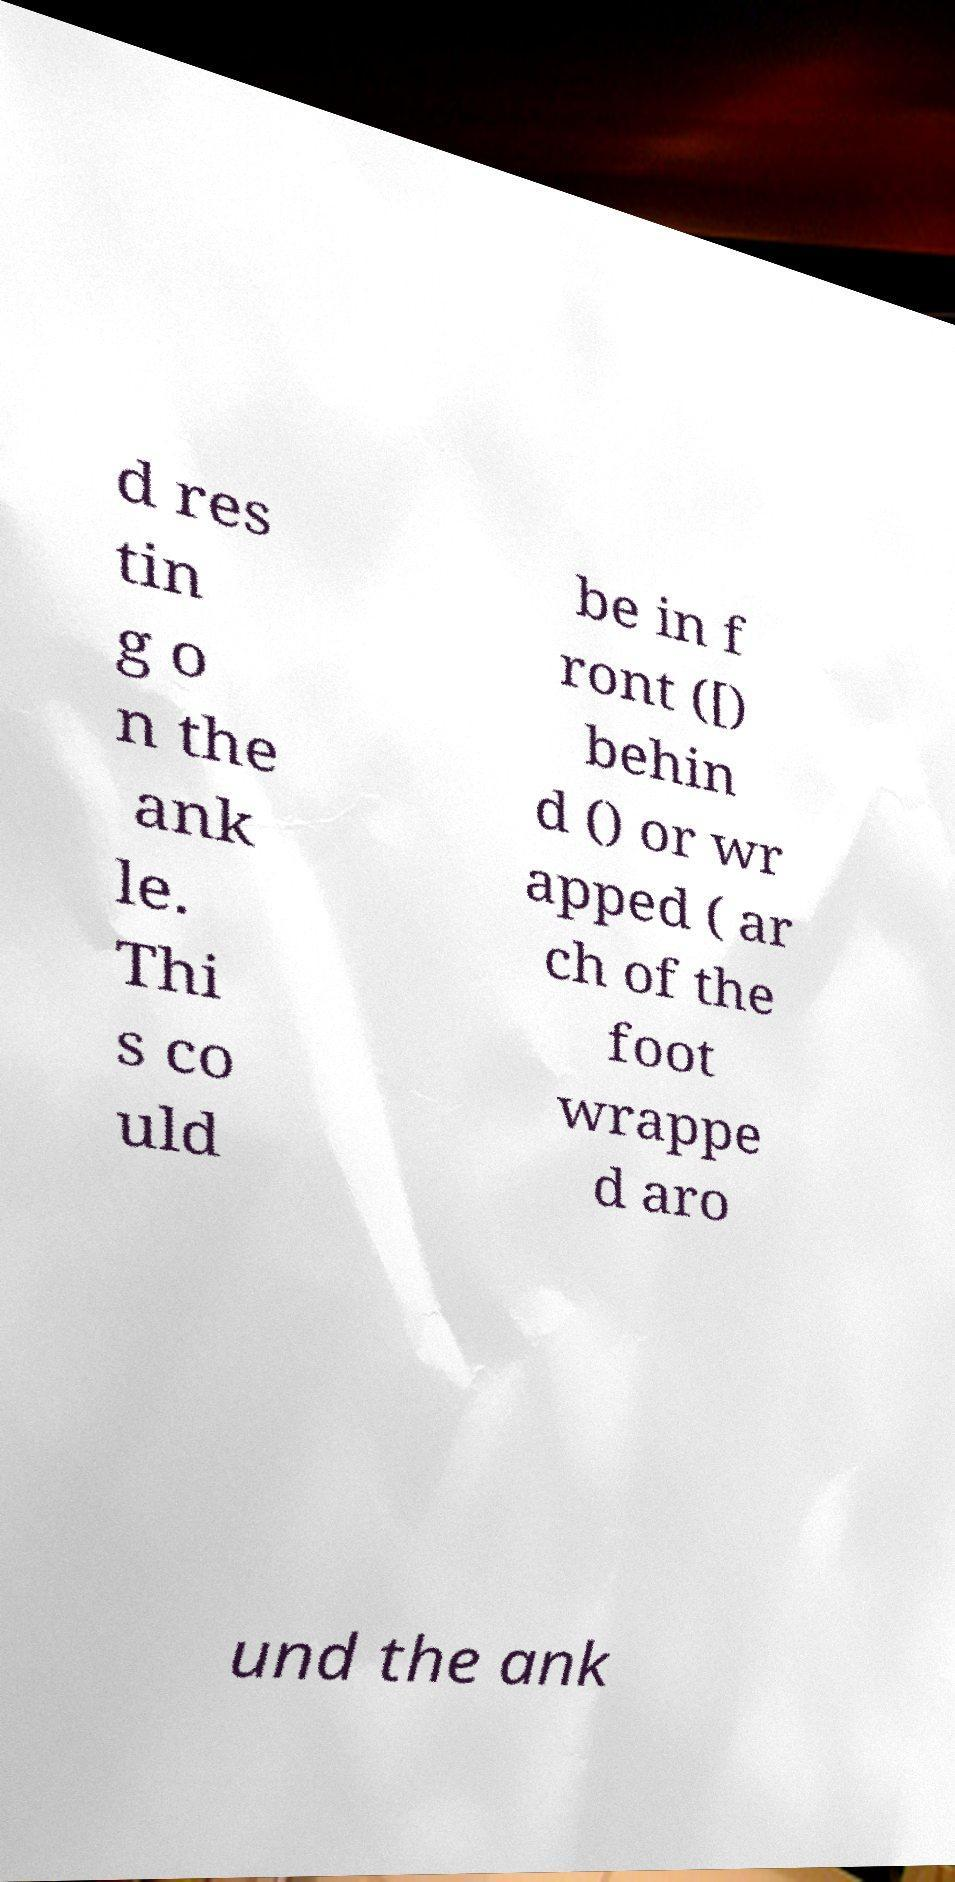I need the written content from this picture converted into text. Can you do that? d res tin g o n the ank le. Thi s co uld be in f ront ([) behin d () or wr apped ( ar ch of the foot wrappe d aro und the ank 